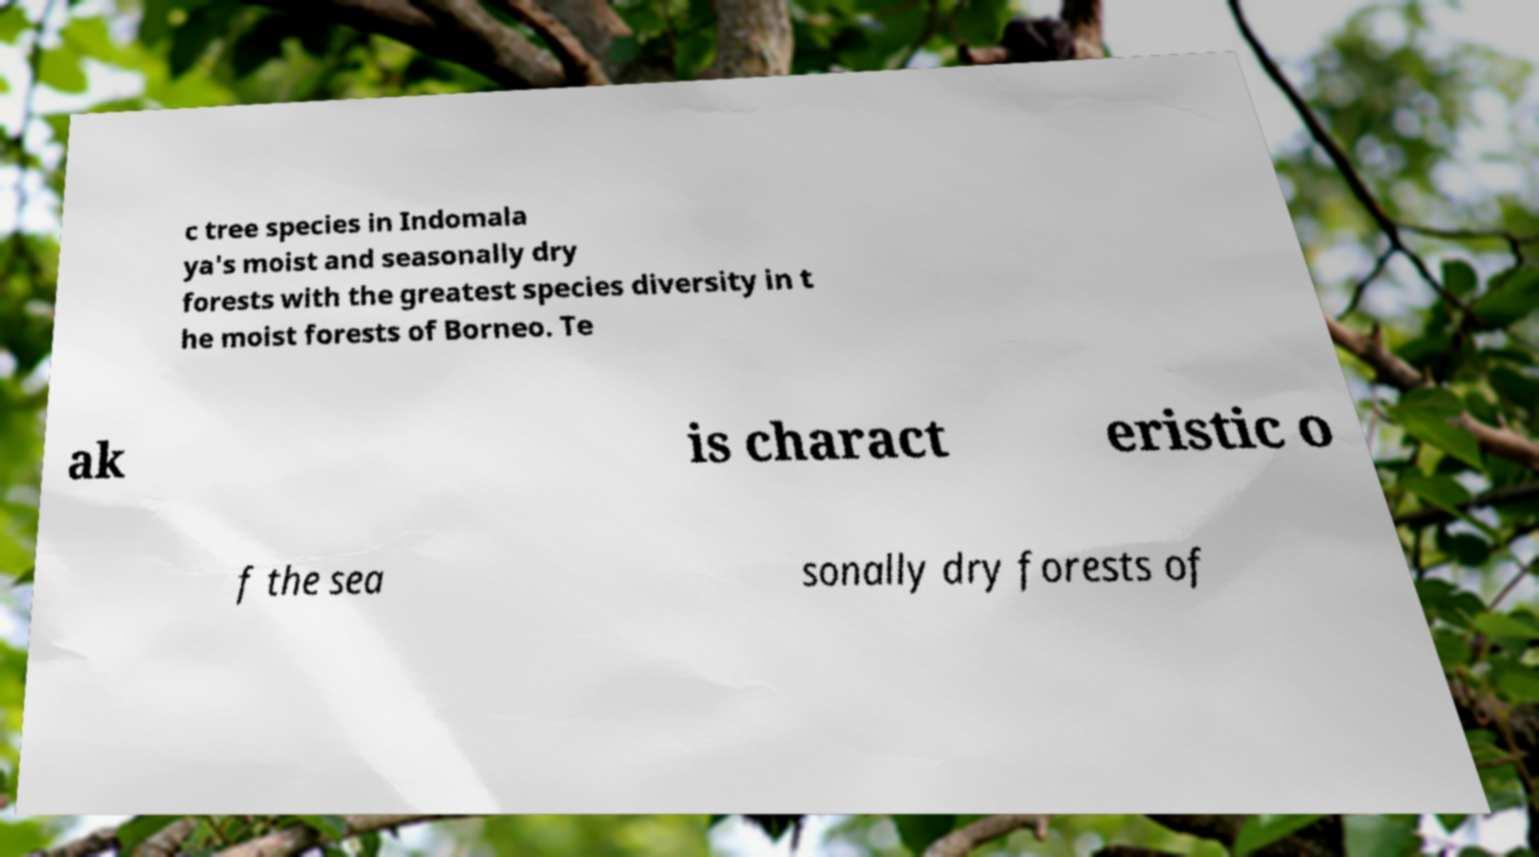What messages or text are displayed in this image? I need them in a readable, typed format. c tree species in Indomala ya's moist and seasonally dry forests with the greatest species diversity in t he moist forests of Borneo. Te ak is charact eristic o f the sea sonally dry forests of 